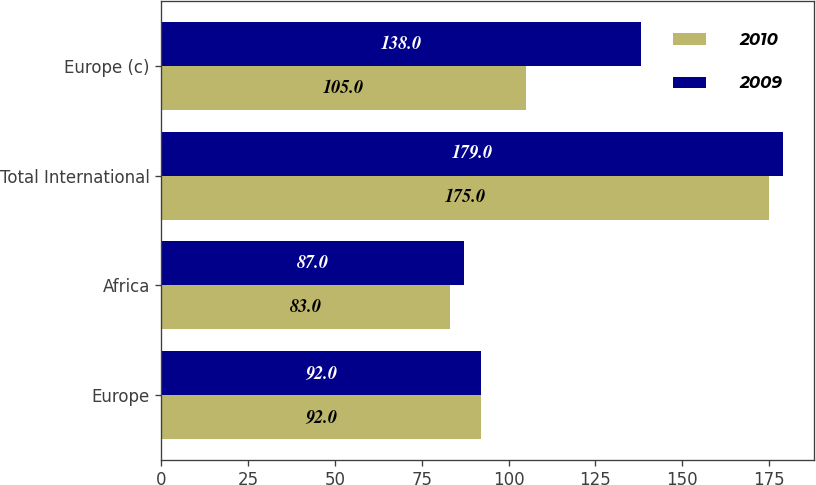<chart> <loc_0><loc_0><loc_500><loc_500><stacked_bar_chart><ecel><fcel>Europe<fcel>Africa<fcel>Total International<fcel>Europe (c)<nl><fcel>2010<fcel>92<fcel>83<fcel>175<fcel>105<nl><fcel>2009<fcel>92<fcel>87<fcel>179<fcel>138<nl></chart> 